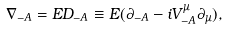<formula> <loc_0><loc_0><loc_500><loc_500>\nabla _ { - A } = E { D } _ { - A } \equiv E ( \partial _ { - A } - i V ^ { \mu } _ { - A } \partial _ { \mu } ) ,</formula> 